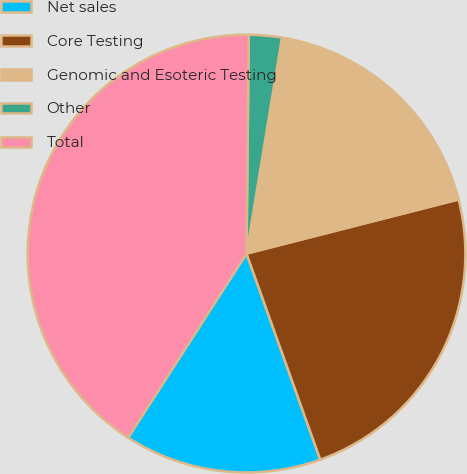<chart> <loc_0><loc_0><loc_500><loc_500><pie_chart><fcel>Net sales<fcel>Core Testing<fcel>Genomic and Esoteric Testing<fcel>Other<fcel>Total<nl><fcel>14.57%<fcel>23.51%<fcel>18.43%<fcel>2.43%<fcel>41.07%<nl></chart> 